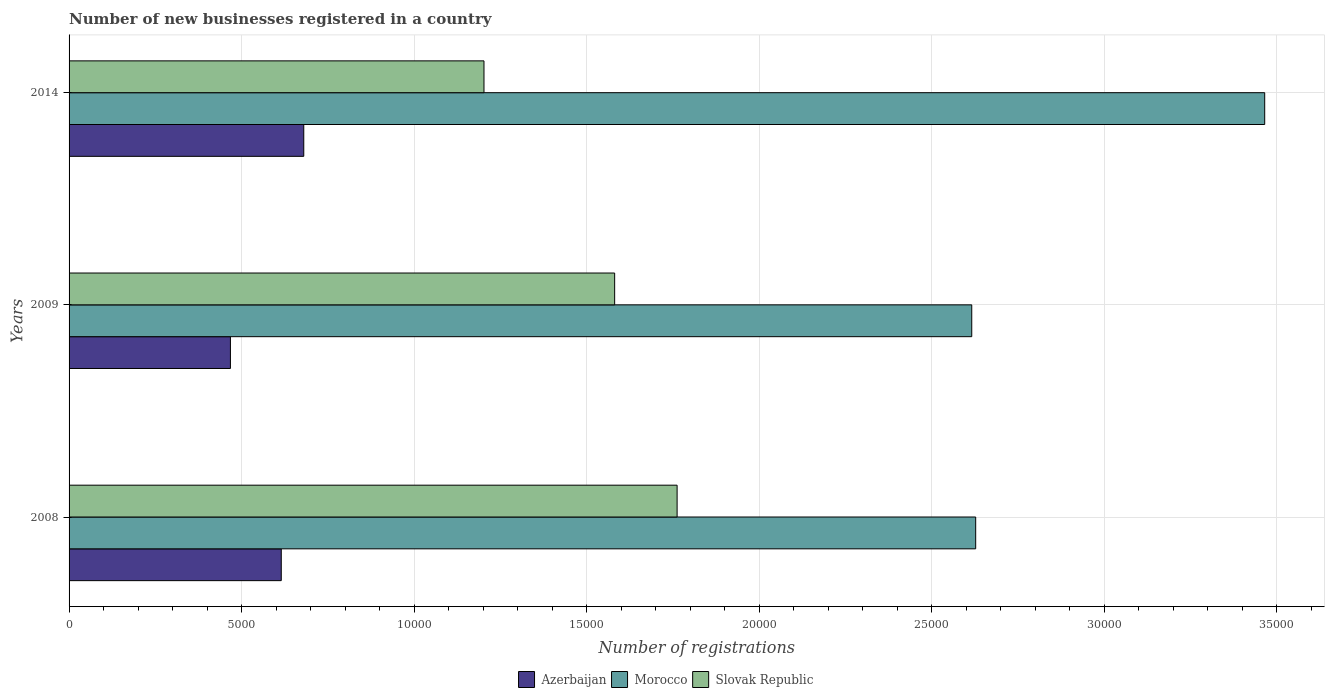How many groups of bars are there?
Offer a terse response. 3. Are the number of bars per tick equal to the number of legend labels?
Your response must be concise. Yes. How many bars are there on the 3rd tick from the top?
Provide a succinct answer. 3. What is the number of new businesses registered in Slovak Republic in 2014?
Ensure brevity in your answer.  1.20e+04. Across all years, what is the maximum number of new businesses registered in Morocco?
Your response must be concise. 3.47e+04. Across all years, what is the minimum number of new businesses registered in Morocco?
Your answer should be compact. 2.62e+04. What is the total number of new businesses registered in Slovak Republic in the graph?
Ensure brevity in your answer.  4.55e+04. What is the difference between the number of new businesses registered in Slovak Republic in 2009 and that in 2014?
Make the answer very short. 3788. What is the difference between the number of new businesses registered in Azerbaijan in 2009 and the number of new businesses registered in Slovak Republic in 2008?
Give a very brief answer. -1.29e+04. What is the average number of new businesses registered in Azerbaijan per year?
Your answer should be very brief. 5877. In the year 2009, what is the difference between the number of new businesses registered in Azerbaijan and number of new businesses registered in Slovak Republic?
Your answer should be compact. -1.11e+04. In how many years, is the number of new businesses registered in Morocco greater than 10000 ?
Keep it short and to the point. 3. What is the ratio of the number of new businesses registered in Morocco in 2008 to that in 2009?
Provide a short and direct response. 1. What is the difference between the highest and the second highest number of new businesses registered in Slovak Republic?
Your answer should be very brief. 1810. What is the difference between the highest and the lowest number of new businesses registered in Azerbaijan?
Offer a terse response. 2126. What does the 3rd bar from the top in 2014 represents?
Give a very brief answer. Azerbaijan. What does the 3rd bar from the bottom in 2008 represents?
Your answer should be very brief. Slovak Republic. How many bars are there?
Provide a succinct answer. 9. Are all the bars in the graph horizontal?
Provide a short and direct response. Yes. How many years are there in the graph?
Give a very brief answer. 3. How many legend labels are there?
Provide a short and direct response. 3. How are the legend labels stacked?
Keep it short and to the point. Horizontal. What is the title of the graph?
Offer a very short reply. Number of new businesses registered in a country. Does "Libya" appear as one of the legend labels in the graph?
Your answer should be very brief. No. What is the label or title of the X-axis?
Your answer should be very brief. Number of registrations. What is the Number of registrations in Azerbaijan in 2008?
Keep it short and to the point. 6151. What is the Number of registrations of Morocco in 2008?
Offer a terse response. 2.63e+04. What is the Number of registrations in Slovak Republic in 2008?
Your answer should be compact. 1.76e+04. What is the Number of registrations in Azerbaijan in 2009?
Ensure brevity in your answer.  4677. What is the Number of registrations in Morocco in 2009?
Provide a succinct answer. 2.62e+04. What is the Number of registrations in Slovak Republic in 2009?
Give a very brief answer. 1.58e+04. What is the Number of registrations in Azerbaijan in 2014?
Your answer should be very brief. 6803. What is the Number of registrations in Morocco in 2014?
Make the answer very short. 3.47e+04. What is the Number of registrations of Slovak Republic in 2014?
Offer a very short reply. 1.20e+04. Across all years, what is the maximum Number of registrations of Azerbaijan?
Make the answer very short. 6803. Across all years, what is the maximum Number of registrations in Morocco?
Give a very brief answer. 3.47e+04. Across all years, what is the maximum Number of registrations of Slovak Republic?
Make the answer very short. 1.76e+04. Across all years, what is the minimum Number of registrations of Azerbaijan?
Make the answer very short. 4677. Across all years, what is the minimum Number of registrations in Morocco?
Your response must be concise. 2.62e+04. Across all years, what is the minimum Number of registrations of Slovak Republic?
Ensure brevity in your answer.  1.20e+04. What is the total Number of registrations of Azerbaijan in the graph?
Provide a short and direct response. 1.76e+04. What is the total Number of registrations in Morocco in the graph?
Ensure brevity in your answer.  8.71e+04. What is the total Number of registrations in Slovak Republic in the graph?
Your answer should be compact. 4.55e+04. What is the difference between the Number of registrations of Azerbaijan in 2008 and that in 2009?
Ensure brevity in your answer.  1474. What is the difference between the Number of registrations of Morocco in 2008 and that in 2009?
Your response must be concise. 114. What is the difference between the Number of registrations in Slovak Republic in 2008 and that in 2009?
Your answer should be very brief. 1810. What is the difference between the Number of registrations in Azerbaijan in 2008 and that in 2014?
Your response must be concise. -652. What is the difference between the Number of registrations in Morocco in 2008 and that in 2014?
Offer a terse response. -8378. What is the difference between the Number of registrations of Slovak Republic in 2008 and that in 2014?
Your answer should be very brief. 5598. What is the difference between the Number of registrations of Azerbaijan in 2009 and that in 2014?
Offer a terse response. -2126. What is the difference between the Number of registrations in Morocco in 2009 and that in 2014?
Offer a terse response. -8492. What is the difference between the Number of registrations of Slovak Republic in 2009 and that in 2014?
Your answer should be very brief. 3788. What is the difference between the Number of registrations of Azerbaijan in 2008 and the Number of registrations of Morocco in 2009?
Your response must be concise. -2.00e+04. What is the difference between the Number of registrations in Azerbaijan in 2008 and the Number of registrations in Slovak Republic in 2009?
Keep it short and to the point. -9664. What is the difference between the Number of registrations in Morocco in 2008 and the Number of registrations in Slovak Republic in 2009?
Provide a short and direct response. 1.05e+04. What is the difference between the Number of registrations of Azerbaijan in 2008 and the Number of registrations of Morocco in 2014?
Your response must be concise. -2.85e+04. What is the difference between the Number of registrations of Azerbaijan in 2008 and the Number of registrations of Slovak Republic in 2014?
Make the answer very short. -5876. What is the difference between the Number of registrations of Morocco in 2008 and the Number of registrations of Slovak Republic in 2014?
Provide a succinct answer. 1.43e+04. What is the difference between the Number of registrations of Azerbaijan in 2009 and the Number of registrations of Morocco in 2014?
Your answer should be very brief. -3.00e+04. What is the difference between the Number of registrations in Azerbaijan in 2009 and the Number of registrations in Slovak Republic in 2014?
Ensure brevity in your answer.  -7350. What is the difference between the Number of registrations in Morocco in 2009 and the Number of registrations in Slovak Republic in 2014?
Offer a very short reply. 1.41e+04. What is the average Number of registrations in Azerbaijan per year?
Your answer should be compact. 5877. What is the average Number of registrations in Morocco per year?
Your answer should be very brief. 2.90e+04. What is the average Number of registrations in Slovak Republic per year?
Give a very brief answer. 1.52e+04. In the year 2008, what is the difference between the Number of registrations in Azerbaijan and Number of registrations in Morocco?
Provide a short and direct response. -2.01e+04. In the year 2008, what is the difference between the Number of registrations of Azerbaijan and Number of registrations of Slovak Republic?
Your response must be concise. -1.15e+04. In the year 2008, what is the difference between the Number of registrations in Morocco and Number of registrations in Slovak Republic?
Ensure brevity in your answer.  8655. In the year 2009, what is the difference between the Number of registrations in Azerbaijan and Number of registrations in Morocco?
Your response must be concise. -2.15e+04. In the year 2009, what is the difference between the Number of registrations in Azerbaijan and Number of registrations in Slovak Republic?
Provide a succinct answer. -1.11e+04. In the year 2009, what is the difference between the Number of registrations in Morocco and Number of registrations in Slovak Republic?
Provide a succinct answer. 1.04e+04. In the year 2014, what is the difference between the Number of registrations in Azerbaijan and Number of registrations in Morocco?
Your response must be concise. -2.79e+04. In the year 2014, what is the difference between the Number of registrations in Azerbaijan and Number of registrations in Slovak Republic?
Keep it short and to the point. -5224. In the year 2014, what is the difference between the Number of registrations in Morocco and Number of registrations in Slovak Republic?
Ensure brevity in your answer.  2.26e+04. What is the ratio of the Number of registrations in Azerbaijan in 2008 to that in 2009?
Your answer should be very brief. 1.32. What is the ratio of the Number of registrations in Morocco in 2008 to that in 2009?
Offer a terse response. 1. What is the ratio of the Number of registrations of Slovak Republic in 2008 to that in 2009?
Ensure brevity in your answer.  1.11. What is the ratio of the Number of registrations of Azerbaijan in 2008 to that in 2014?
Ensure brevity in your answer.  0.9. What is the ratio of the Number of registrations of Morocco in 2008 to that in 2014?
Give a very brief answer. 0.76. What is the ratio of the Number of registrations of Slovak Republic in 2008 to that in 2014?
Your answer should be compact. 1.47. What is the ratio of the Number of registrations of Azerbaijan in 2009 to that in 2014?
Ensure brevity in your answer.  0.69. What is the ratio of the Number of registrations of Morocco in 2009 to that in 2014?
Ensure brevity in your answer.  0.76. What is the ratio of the Number of registrations of Slovak Republic in 2009 to that in 2014?
Your answer should be compact. 1.31. What is the difference between the highest and the second highest Number of registrations of Azerbaijan?
Offer a very short reply. 652. What is the difference between the highest and the second highest Number of registrations of Morocco?
Offer a very short reply. 8378. What is the difference between the highest and the second highest Number of registrations of Slovak Republic?
Ensure brevity in your answer.  1810. What is the difference between the highest and the lowest Number of registrations in Azerbaijan?
Provide a short and direct response. 2126. What is the difference between the highest and the lowest Number of registrations in Morocco?
Provide a short and direct response. 8492. What is the difference between the highest and the lowest Number of registrations of Slovak Republic?
Your answer should be very brief. 5598. 